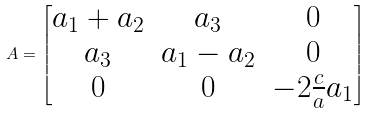Convert formula to latex. <formula><loc_0><loc_0><loc_500><loc_500>A = \begin{bmatrix} a _ { 1 } + a _ { 2 } & a _ { 3 } & 0 \\ a _ { 3 } & a _ { 1 } - a _ { 2 } & 0 \\ 0 & 0 & - 2 \frac { c } { a } a _ { 1 } \end{bmatrix}</formula> 